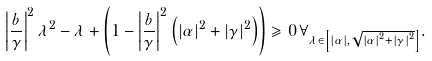<formula> <loc_0><loc_0><loc_500><loc_500>\left | \frac { b } { \gamma } \right | ^ { 2 } \lambda ^ { 2 } - \lambda + \left ( 1 - \left | \frac { b } { \gamma } \right | ^ { 2 } \left ( \left | \alpha \right | ^ { 2 } + \left | \gamma \right | ^ { 2 } \right ) \right ) \geqslant 0 \, \forall _ { \lambda \in \left [ \left | \alpha \right | , \sqrt { \left | \alpha \right | ^ { 2 } + \left | \gamma \right | ^ { 2 } } \right ] } .</formula> 